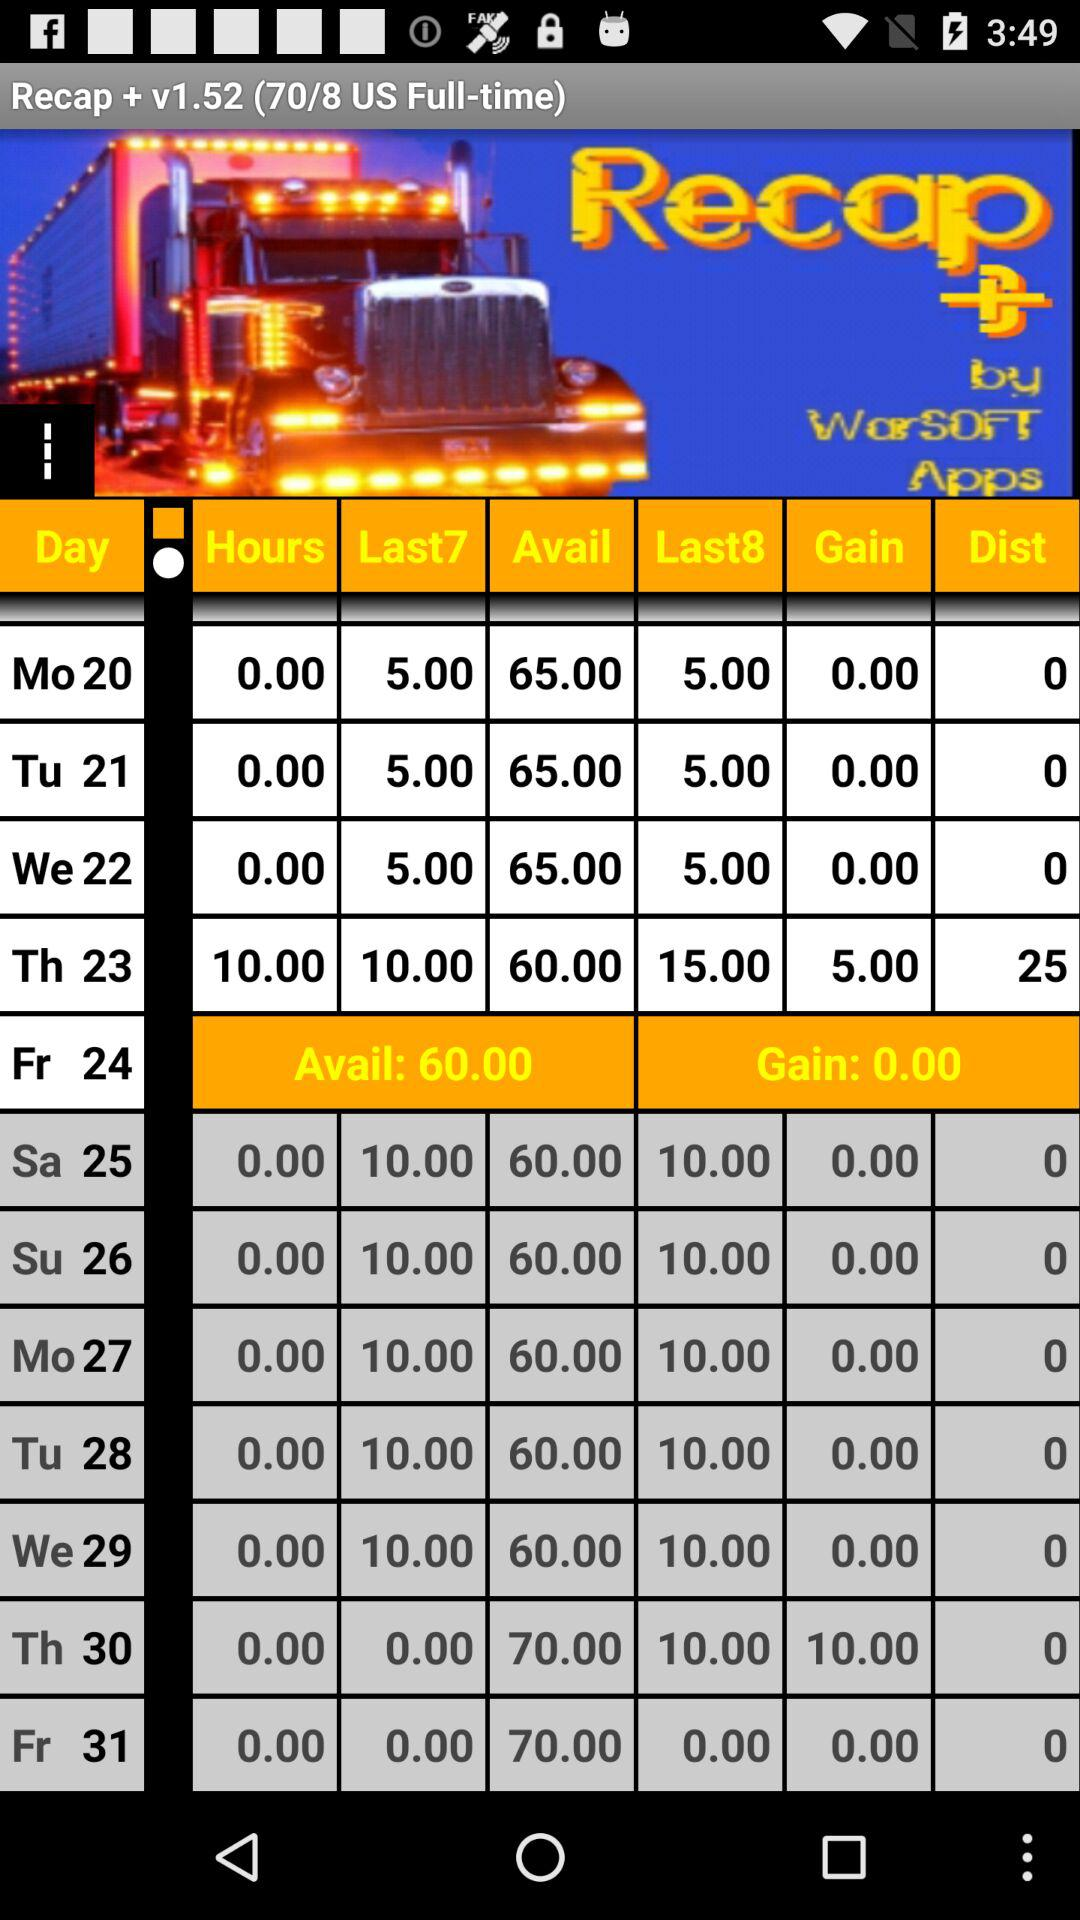What's the "Avail" on the 24th? The "Avail" on the 24th is 60. 